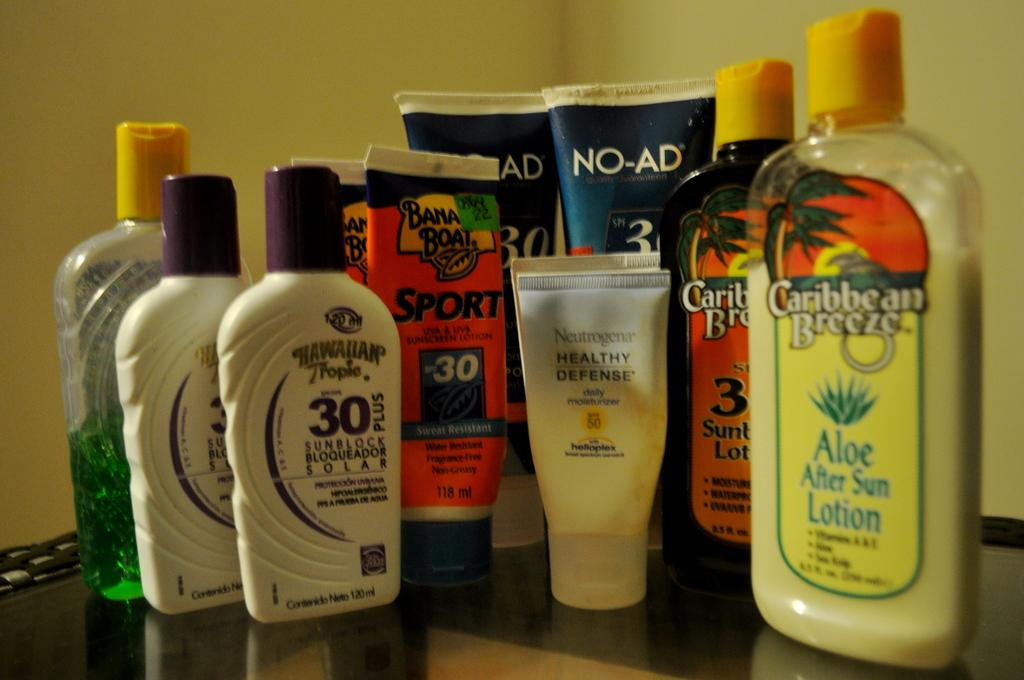<image>
Summarize the visual content of the image. Many bottles on top of a table including "Caribbean Breeze" on the right. 